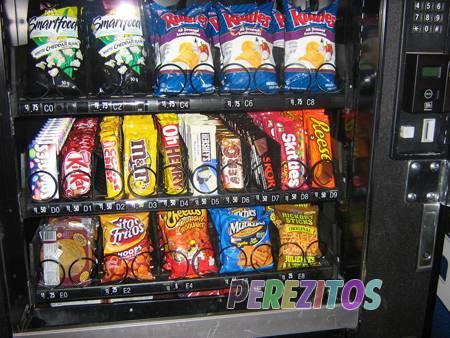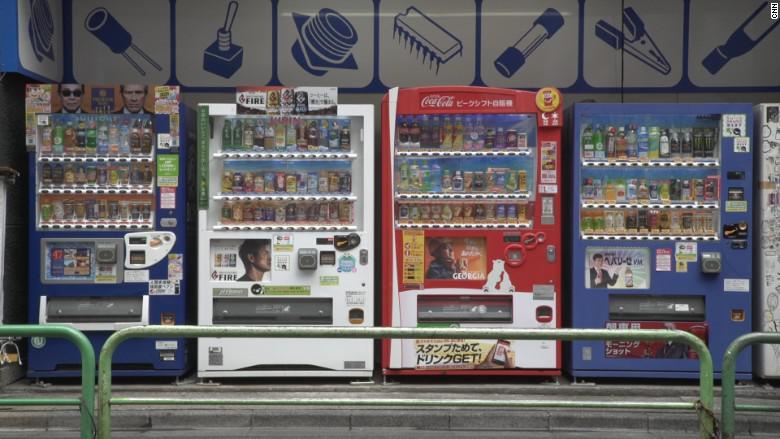The first image is the image on the left, the second image is the image on the right. Given the left and right images, does the statement "A bank of exactly three vending machines appears in one image." hold true? Answer yes or no. No. The first image is the image on the left, the second image is the image on the right. Assess this claim about the two images: "An image shows a row of exactly three vending machines.". Correct or not? Answer yes or no. No. 